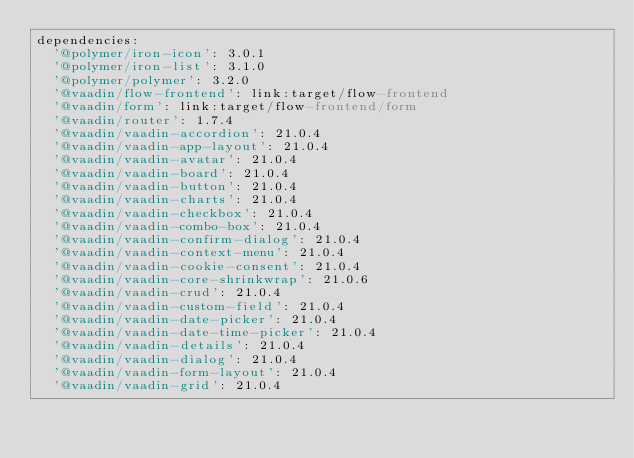Convert code to text. <code><loc_0><loc_0><loc_500><loc_500><_YAML_>dependencies:
  '@polymer/iron-icon': 3.0.1
  '@polymer/iron-list': 3.1.0
  '@polymer/polymer': 3.2.0
  '@vaadin/flow-frontend': link:target/flow-frontend
  '@vaadin/form': link:target/flow-frontend/form
  '@vaadin/router': 1.7.4
  '@vaadin/vaadin-accordion': 21.0.4
  '@vaadin/vaadin-app-layout': 21.0.4
  '@vaadin/vaadin-avatar': 21.0.4
  '@vaadin/vaadin-board': 21.0.4
  '@vaadin/vaadin-button': 21.0.4
  '@vaadin/vaadin-charts': 21.0.4
  '@vaadin/vaadin-checkbox': 21.0.4
  '@vaadin/vaadin-combo-box': 21.0.4
  '@vaadin/vaadin-confirm-dialog': 21.0.4
  '@vaadin/vaadin-context-menu': 21.0.4
  '@vaadin/vaadin-cookie-consent': 21.0.4
  '@vaadin/vaadin-core-shrinkwrap': 21.0.6
  '@vaadin/vaadin-crud': 21.0.4
  '@vaadin/vaadin-custom-field': 21.0.4
  '@vaadin/vaadin-date-picker': 21.0.4
  '@vaadin/vaadin-date-time-picker': 21.0.4
  '@vaadin/vaadin-details': 21.0.4
  '@vaadin/vaadin-dialog': 21.0.4
  '@vaadin/vaadin-form-layout': 21.0.4
  '@vaadin/vaadin-grid': 21.0.4</code> 